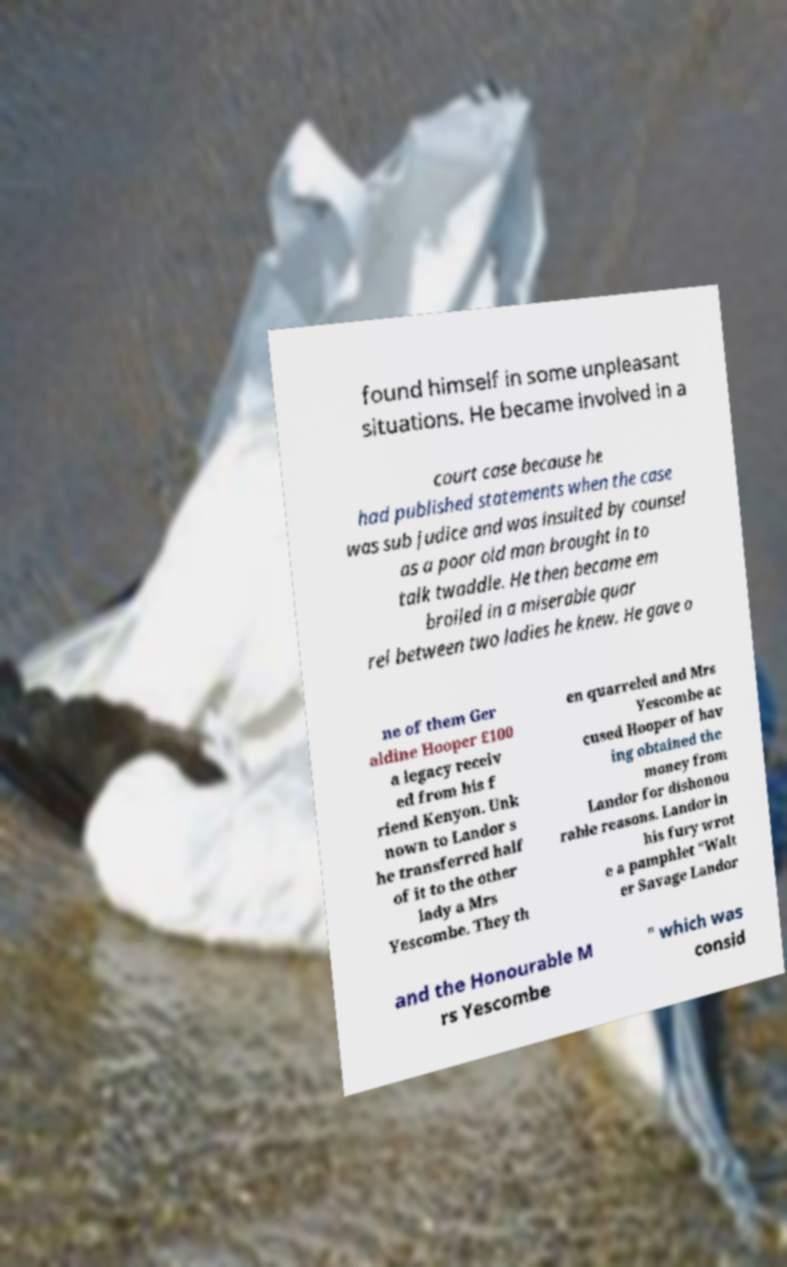Please read and relay the text visible in this image. What does it say? found himself in some unpleasant situations. He became involved in a court case because he had published statements when the case was sub judice and was insulted by counsel as a poor old man brought in to talk twaddle. He then became em broiled in a miserable quar rel between two ladies he knew. He gave o ne of them Ger aldine Hooper £100 a legacy receiv ed from his f riend Kenyon. Unk nown to Landor s he transferred half of it to the other lady a Mrs Yescombe. They th en quarreled and Mrs Yescombe ac cused Hooper of hav ing obtained the money from Landor for dishonou rable reasons. Landor in his fury wrot e a pamphlet "Walt er Savage Landor and the Honourable M rs Yescombe " which was consid 